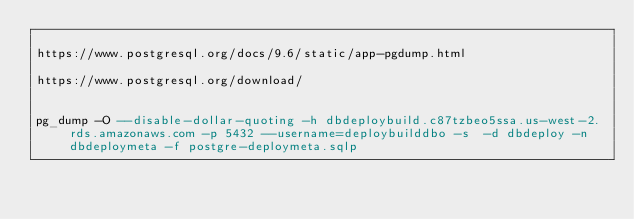<code> <loc_0><loc_0><loc_500><loc_500><_SQL_>
https://www.postgresql.org/docs/9.6/static/app-pgdump.html

https://www.postgresql.org/download/


pg_dump -O --disable-dollar-quoting -h dbdeploybuild.c87tzbeo5ssa.us-west-2.rds.amazonaws.com -p 5432 --username=deploybuilddbo -s  -d dbdeploy -n dbdeploymeta -f postgre-deploymeta.sqlp
</code> 